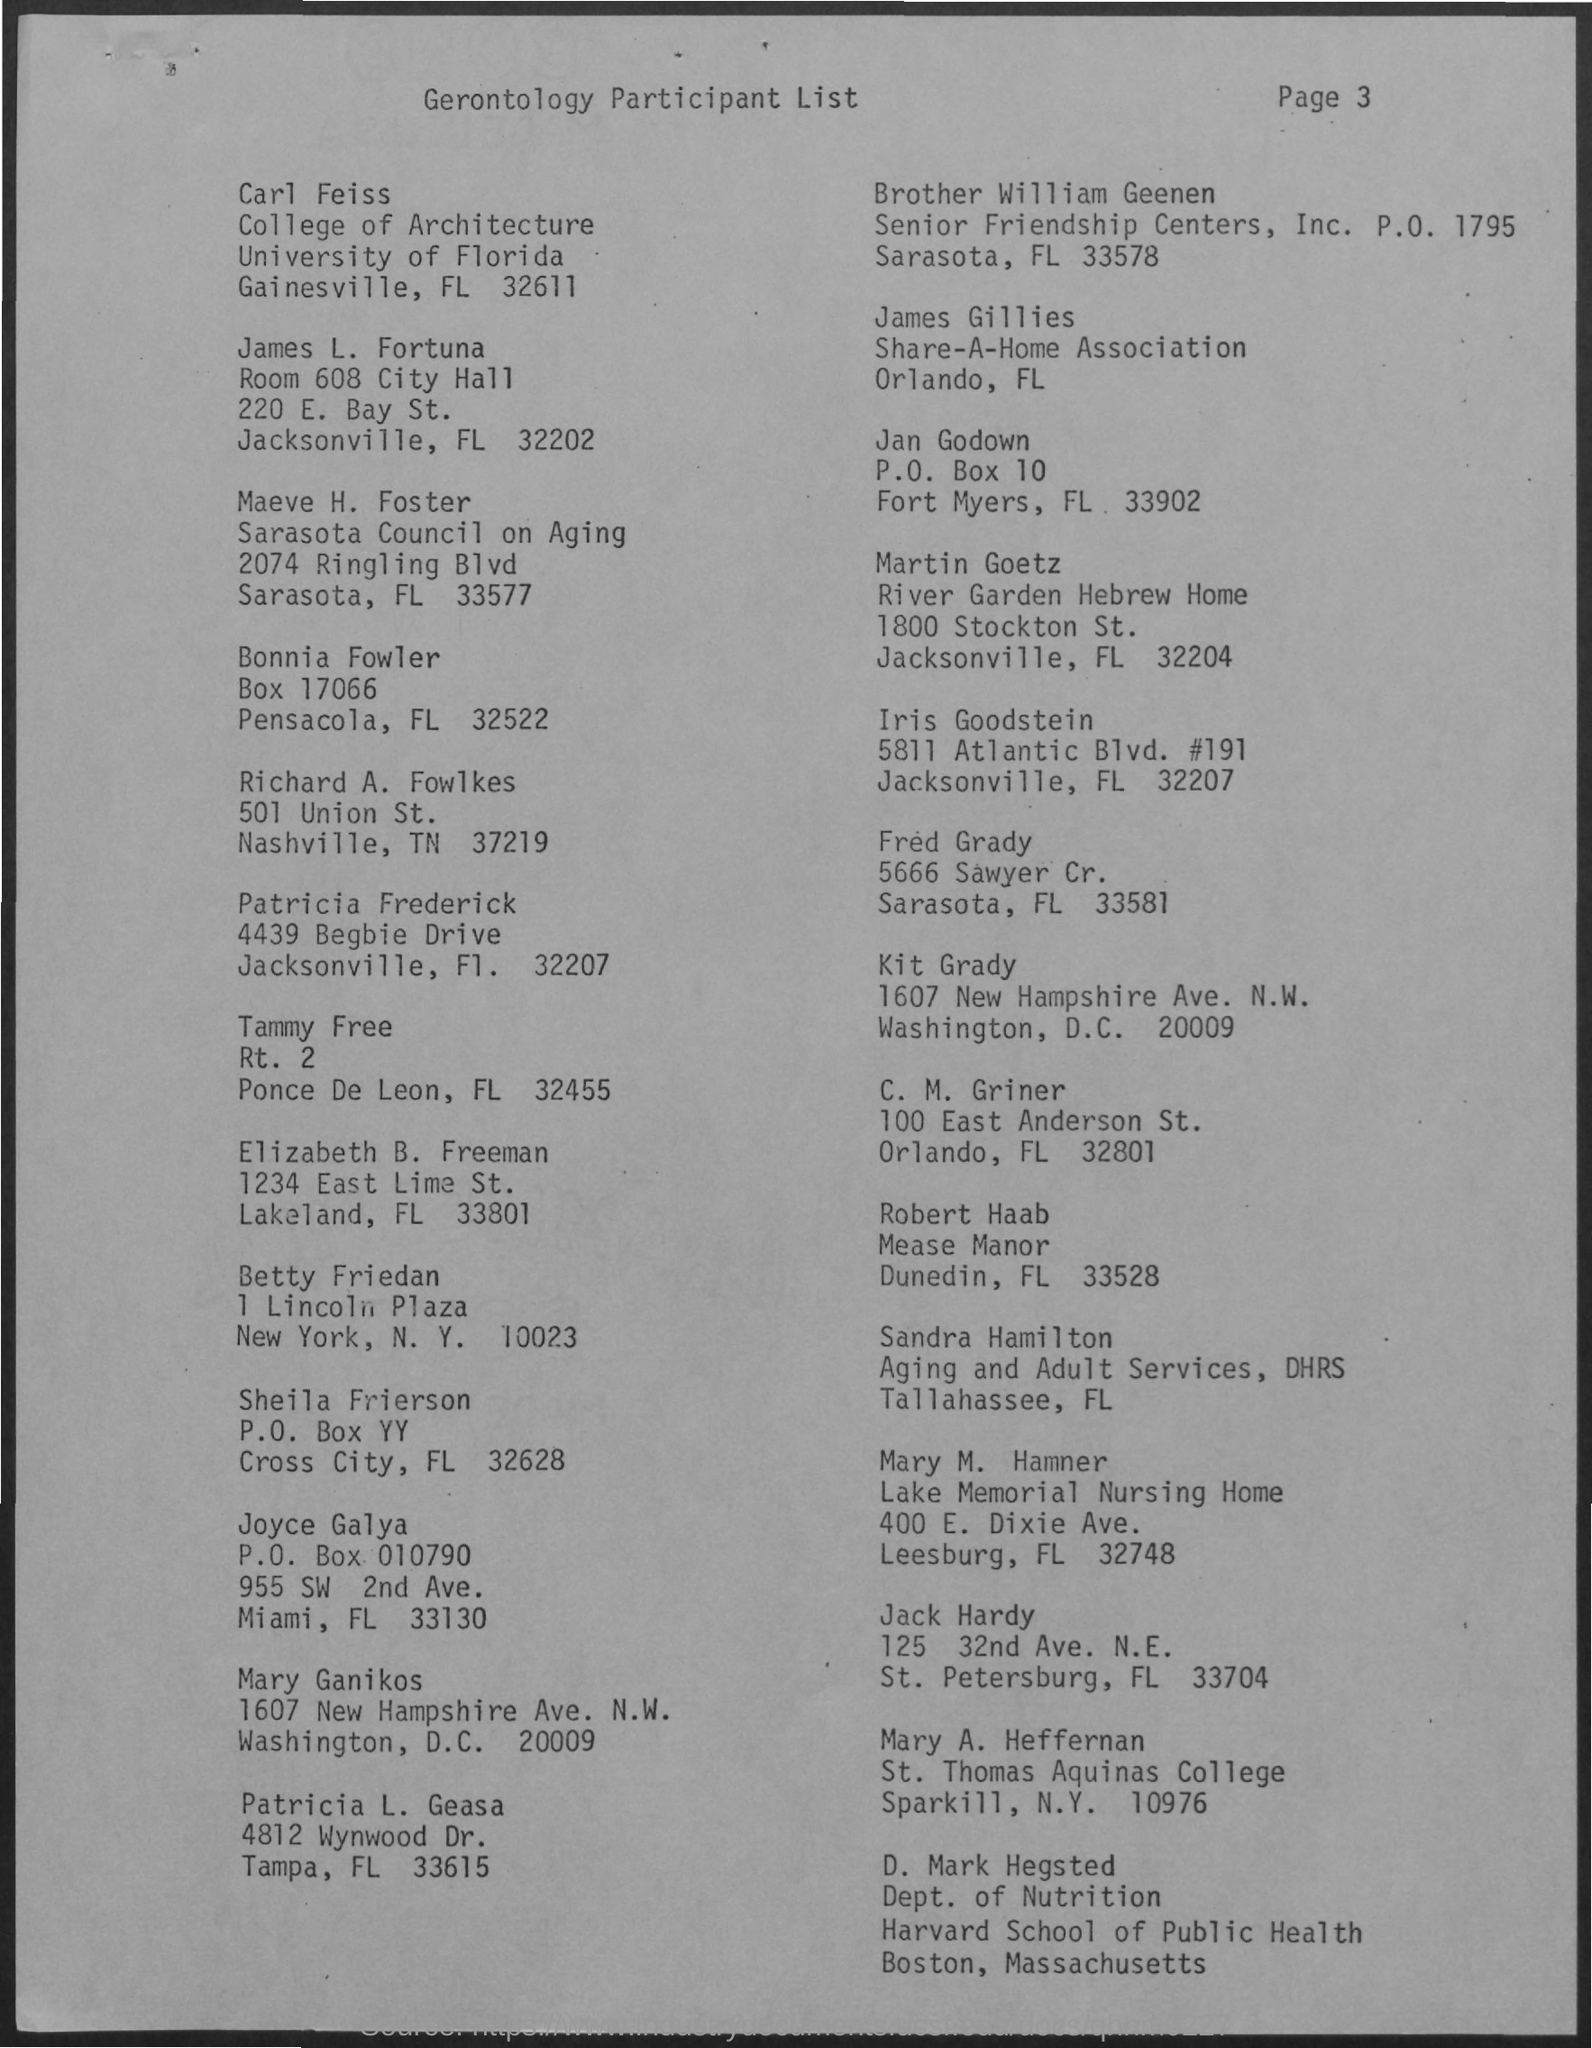To which university  carl feiss belongs to ?
Offer a terse response. University of florida. 